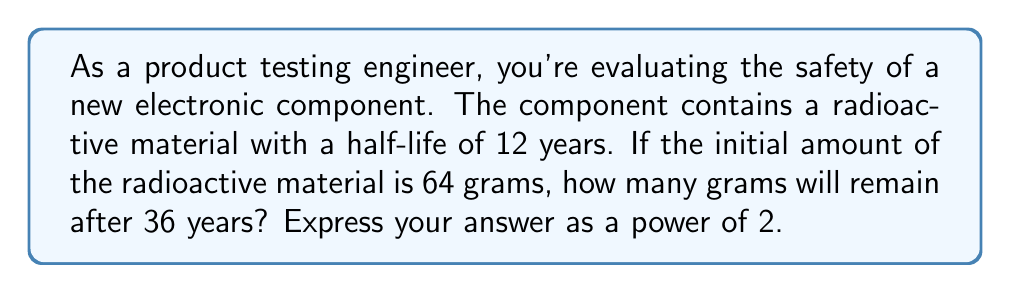Provide a solution to this math problem. Let's approach this step-by-step:

1) The half-life formula is:

   $$A(t) = A_0 \cdot (\frac{1}{2})^{\frac{t}{t_{1/2}}}$$

   Where:
   $A(t)$ is the amount remaining after time $t$
   $A_0$ is the initial amount
   $t$ is the time elapsed
   $t_{1/2}$ is the half-life

2) We know:
   $A_0 = 64$ grams
   $t = 36$ years
   $t_{1/2} = 12$ years

3) Let's substitute these values:

   $$A(36) = 64 \cdot (\frac{1}{2})^{\frac{36}{12}}$$

4) Simplify the exponent:

   $$A(36) = 64 \cdot (\frac{1}{2})^3$$

5) Calculate $(\frac{1}{2})^3$:

   $$A(36) = 64 \cdot \frac{1}{8}$$

6) Simplify:

   $$A(36) = 8$$

7) Express 8 as a power of 2:

   $$A(36) = 2^3$$

Therefore, after 36 years, 8 grams (or $2^3$ grams) of the radioactive material will remain.
Answer: $2^3$ grams 